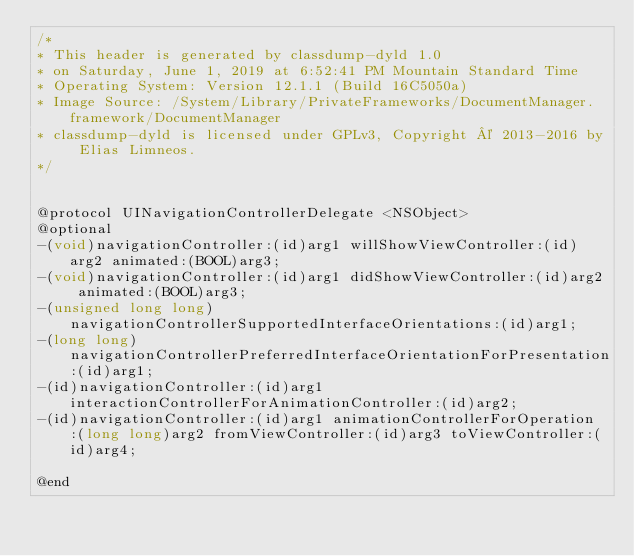<code> <loc_0><loc_0><loc_500><loc_500><_C_>/*
* This header is generated by classdump-dyld 1.0
* on Saturday, June 1, 2019 at 6:52:41 PM Mountain Standard Time
* Operating System: Version 12.1.1 (Build 16C5050a)
* Image Source: /System/Library/PrivateFrameworks/DocumentManager.framework/DocumentManager
* classdump-dyld is licensed under GPLv3, Copyright © 2013-2016 by Elias Limneos.
*/


@protocol UINavigationControllerDelegate <NSObject>
@optional
-(void)navigationController:(id)arg1 willShowViewController:(id)arg2 animated:(BOOL)arg3;
-(void)navigationController:(id)arg1 didShowViewController:(id)arg2 animated:(BOOL)arg3;
-(unsigned long long)navigationControllerSupportedInterfaceOrientations:(id)arg1;
-(long long)navigationControllerPreferredInterfaceOrientationForPresentation:(id)arg1;
-(id)navigationController:(id)arg1 interactionControllerForAnimationController:(id)arg2;
-(id)navigationController:(id)arg1 animationControllerForOperation:(long long)arg2 fromViewController:(id)arg3 toViewController:(id)arg4;

@end

</code> 